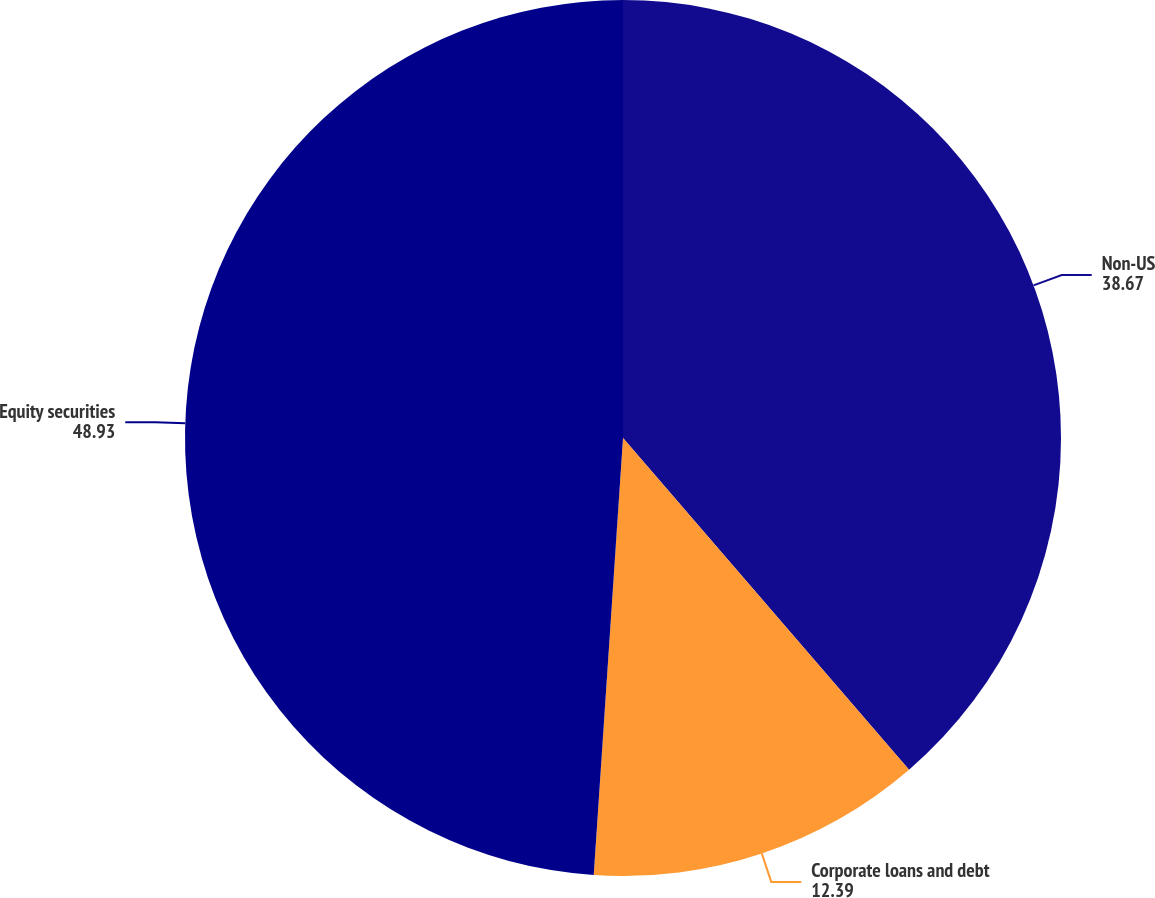Convert chart. <chart><loc_0><loc_0><loc_500><loc_500><pie_chart><fcel>Non-US<fcel>Corporate loans and debt<fcel>Equity securities<nl><fcel>38.67%<fcel>12.39%<fcel>48.93%<nl></chart> 